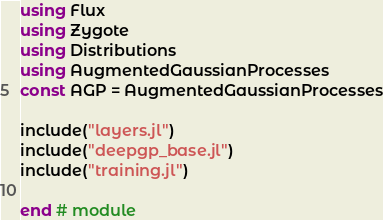<code> <loc_0><loc_0><loc_500><loc_500><_Julia_>using Flux
using Zygote
using Distributions
using AugmentedGaussianProcesses
const AGP = AugmentedGaussianProcesses

include("layers.jl")
include("deepgp_base.jl")
include("training.jl")

end # module
</code> 